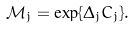<formula> <loc_0><loc_0><loc_500><loc_500>\mathcal { M } _ { j } = \exp \{ \Delta _ { j } C _ { j } \} .</formula> 